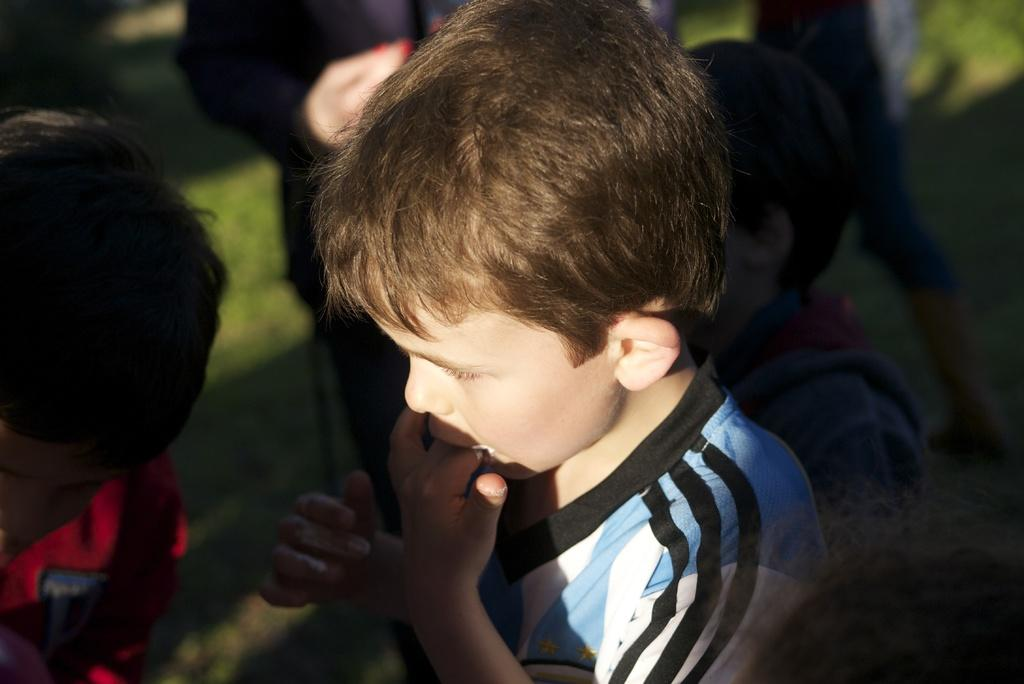Who is the main subject in the image? There is a boy in the image. What is the boy doing in the image? The boy is putting his fingers in his mouth. Are there any other people present in the image? Yes, there are people around the boy. What type of surface is visible on the ground in the image? There is grass on the ground in the image. What type of vein is visible on the boy's forehead in the image? There is no visible vein on the boy's forehead in the image. What type of cushion is the boy sitting on in the image? The image does not show the boy sitting on a cushion; he is standing. 